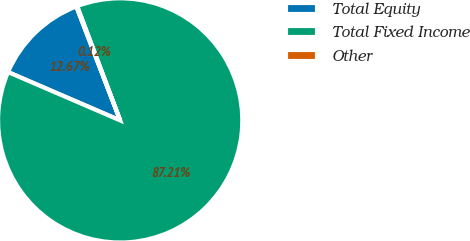Convert chart to OTSL. <chart><loc_0><loc_0><loc_500><loc_500><pie_chart><fcel>Total Equity<fcel>Total Fixed Income<fcel>Other<nl><fcel>12.67%<fcel>87.21%<fcel>0.12%<nl></chart> 